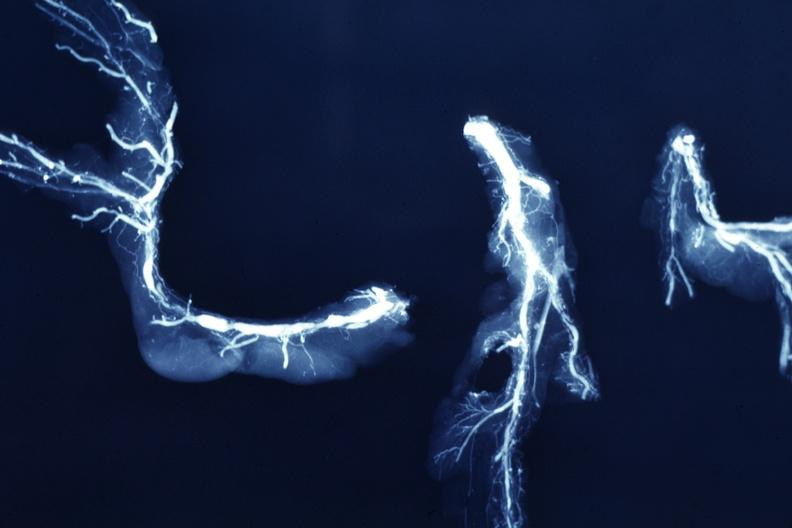what is x-ray postmortdissected?
Answer the question using a single word or phrase. Ray postmortdissected arteries extensive lesions 